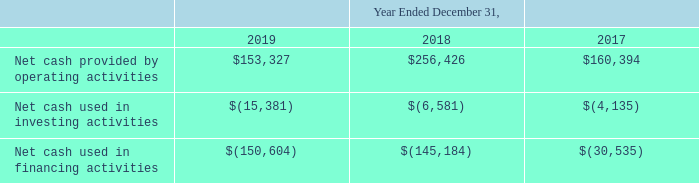ITEM 7. MANAGEMENT'S DISCUSSION AND ANALYSIS OF FINANCIAL CONDITION AND RESULTS OF OPERATIONS (United States Dollars in thousands, except per share data and unless otherwise indicated)
Cash flows
We prepare our Consolidated Statements of Cash Flows using the indirect method, under which we reconcile net income to cash flows provided by operating activities by adjusting net income for those items that impact net income, but may not result in actual cash receipts or payments during the period. The following table provides a summary of our operating, investing and financing cash flows for the periods indicated.
Which years does the table provide information for the company's cash flows? 2019, 2018, 2017. What was the Net cash used in investing activities in 2019?
Answer scale should be: thousand. (15,381). What was the Net cash provided by operating activities in 2017?
Answer scale should be: thousand. 160,394. How many years did the Net cash provided by operating activities exceed $200,000 thousand? 2018
Answer: 1. What was the change in the Net cash used in investing activities between 2017 and 2019?
Answer scale should be: thousand. -15,381-(-4,135)
Answer: -11246. What was the percentage change in the Net cash used in financing activities between 2018 and 2019?
Answer scale should be: percent. (-150,604-(-145,184))/-145,184
Answer: 3.73. 